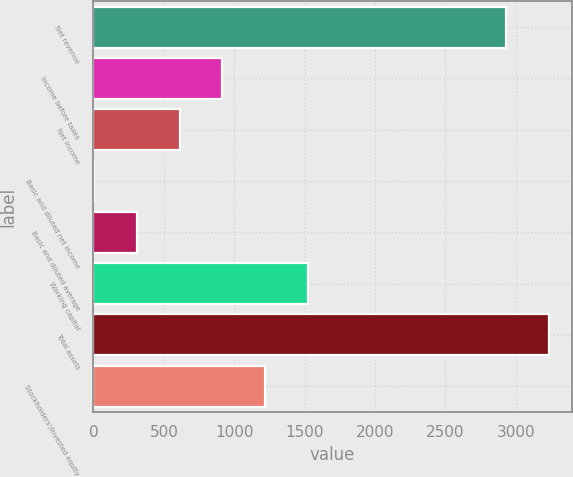Convert chart. <chart><loc_0><loc_0><loc_500><loc_500><bar_chart><fcel>Net revenue<fcel>Income before taxes<fcel>Net income<fcel>Basic and diluted net income<fcel>Basic and diluted average<fcel>Working capital<fcel>Total assets<fcel>Stockholders'/Invested equity<nl><fcel>2933<fcel>916.64<fcel>611.88<fcel>2.35<fcel>307.12<fcel>1526.17<fcel>3237.76<fcel>1221.4<nl></chart> 